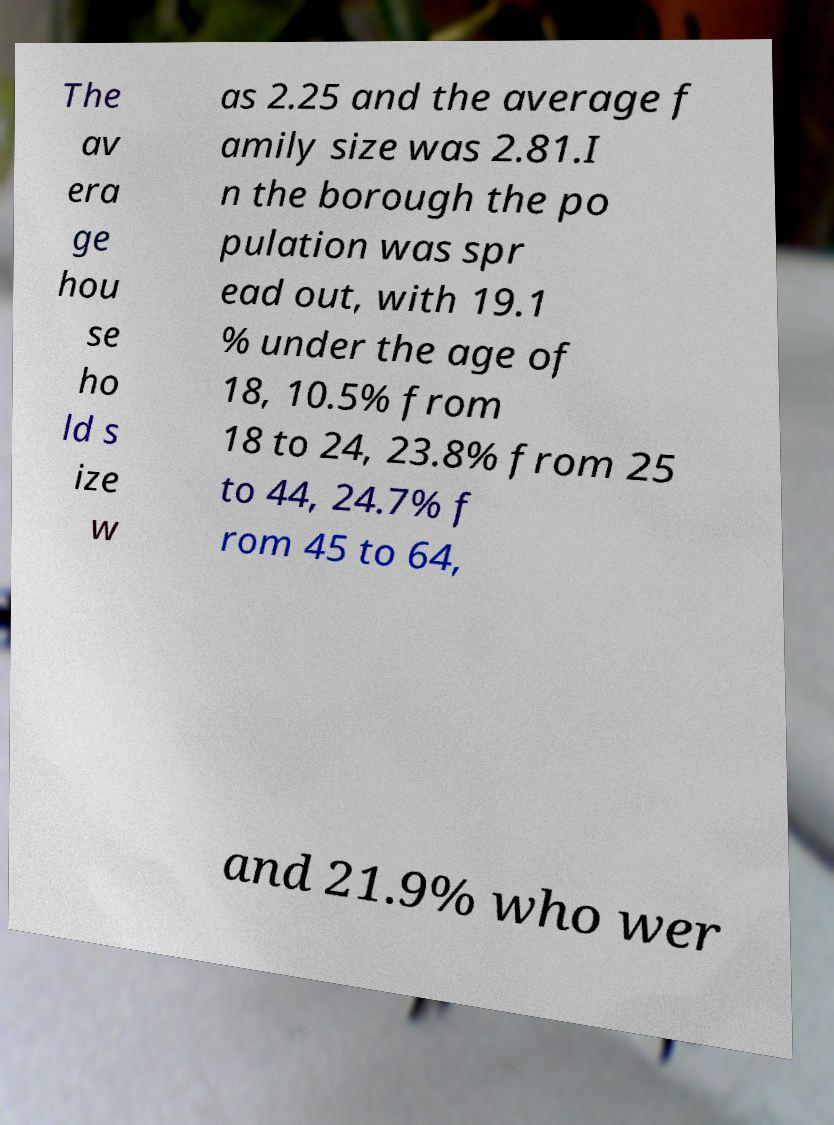Could you assist in decoding the text presented in this image and type it out clearly? The av era ge hou se ho ld s ize w as 2.25 and the average f amily size was 2.81.I n the borough the po pulation was spr ead out, with 19.1 % under the age of 18, 10.5% from 18 to 24, 23.8% from 25 to 44, 24.7% f rom 45 to 64, and 21.9% who wer 